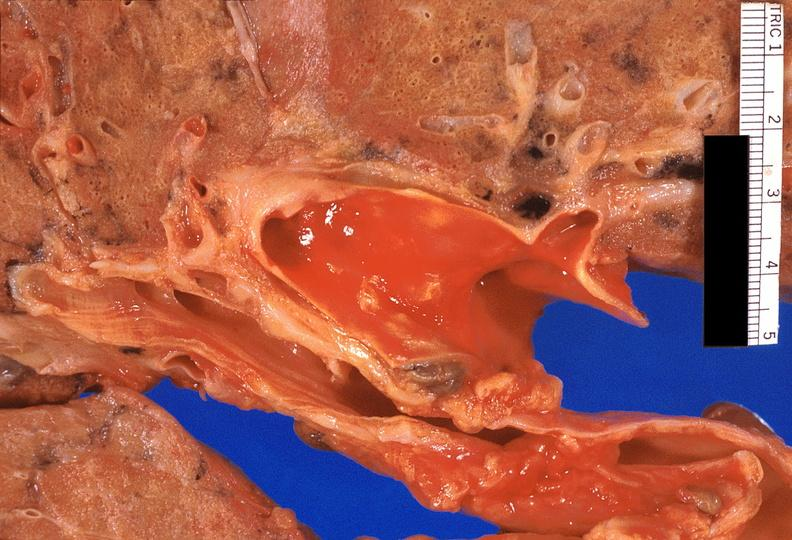s respiratory present?
Answer the question using a single word or phrase. Yes 